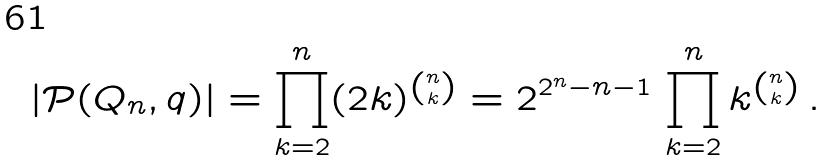Convert formula to latex. <formula><loc_0><loc_0><loc_500><loc_500>| { \mathcal { P } } ( Q _ { n } , q ) | = \prod _ { k = 2 } ^ { n } ( 2 k ) ^ { n \choose k } = 2 ^ { 2 ^ { n } - n - 1 } \, \prod _ { k = 2 } ^ { n } k ^ { n \choose k } \, .</formula> 